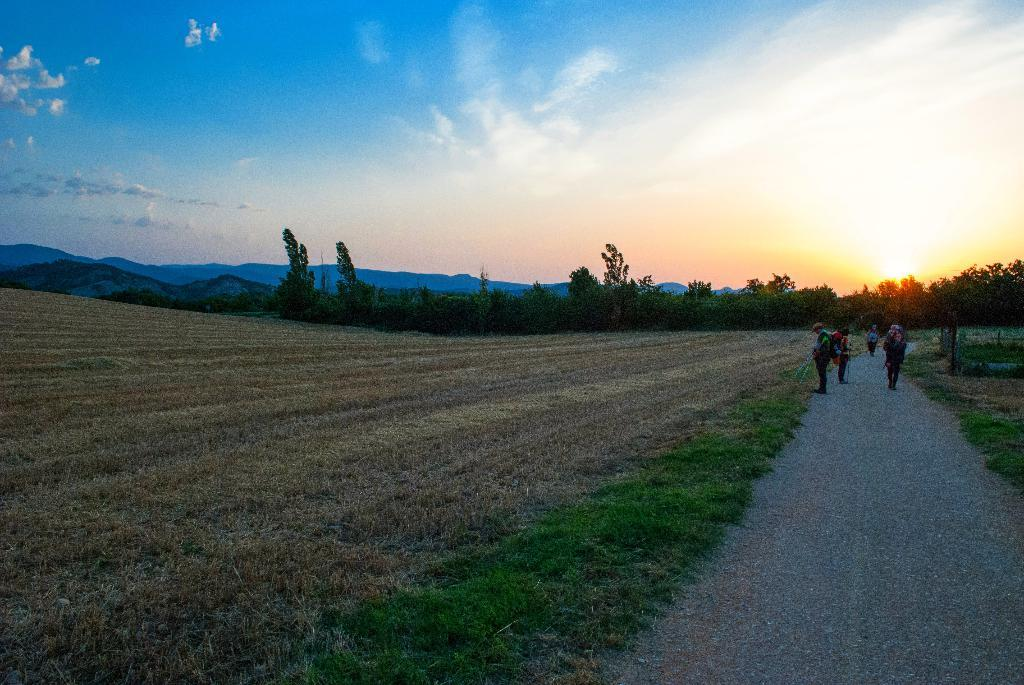What type of natural feature can be seen in the image? There is a tree in the image. Are there any human subjects in the image? Yes, there are people in the image. What is visible in the background of the image? The sky and mountains are visible in the image. What can be seen in the sky in the image? Clouds are present in the image. What book is the person reading during recess in the image? There is no person reading a book during recess in the image, as there is no reference to a book, recess, or any educational setting. 